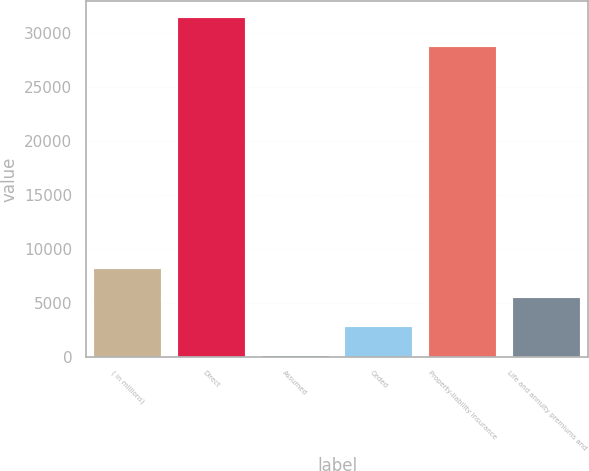Convert chart to OTSL. <chart><loc_0><loc_0><loc_500><loc_500><bar_chart><fcel>( in millions)<fcel>Direct<fcel>Assumed<fcel>Ceded<fcel>Property-liability insurance<fcel>Life and annuity premiums and<nl><fcel>8122.7<fcel>31358.8<fcel>41<fcel>2734.9<fcel>28664.9<fcel>5428.8<nl></chart> 